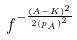<formula> <loc_0><loc_0><loc_500><loc_500>f ^ { - \frac { ( A - K ) ^ { 2 } } { 2 { ( p _ { A } ) } ^ { 2 } } }</formula> 